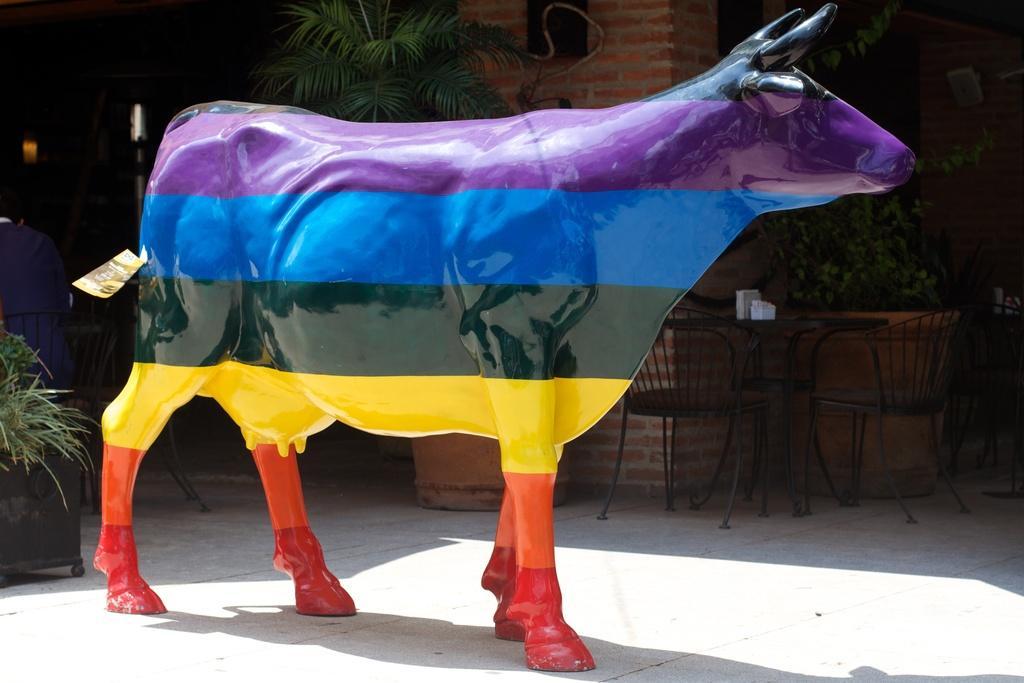Can you describe this image briefly? This image consists of a statue of a cow. It is multi colored one. There is a chair in the middle. There are plants on the left side and top. 